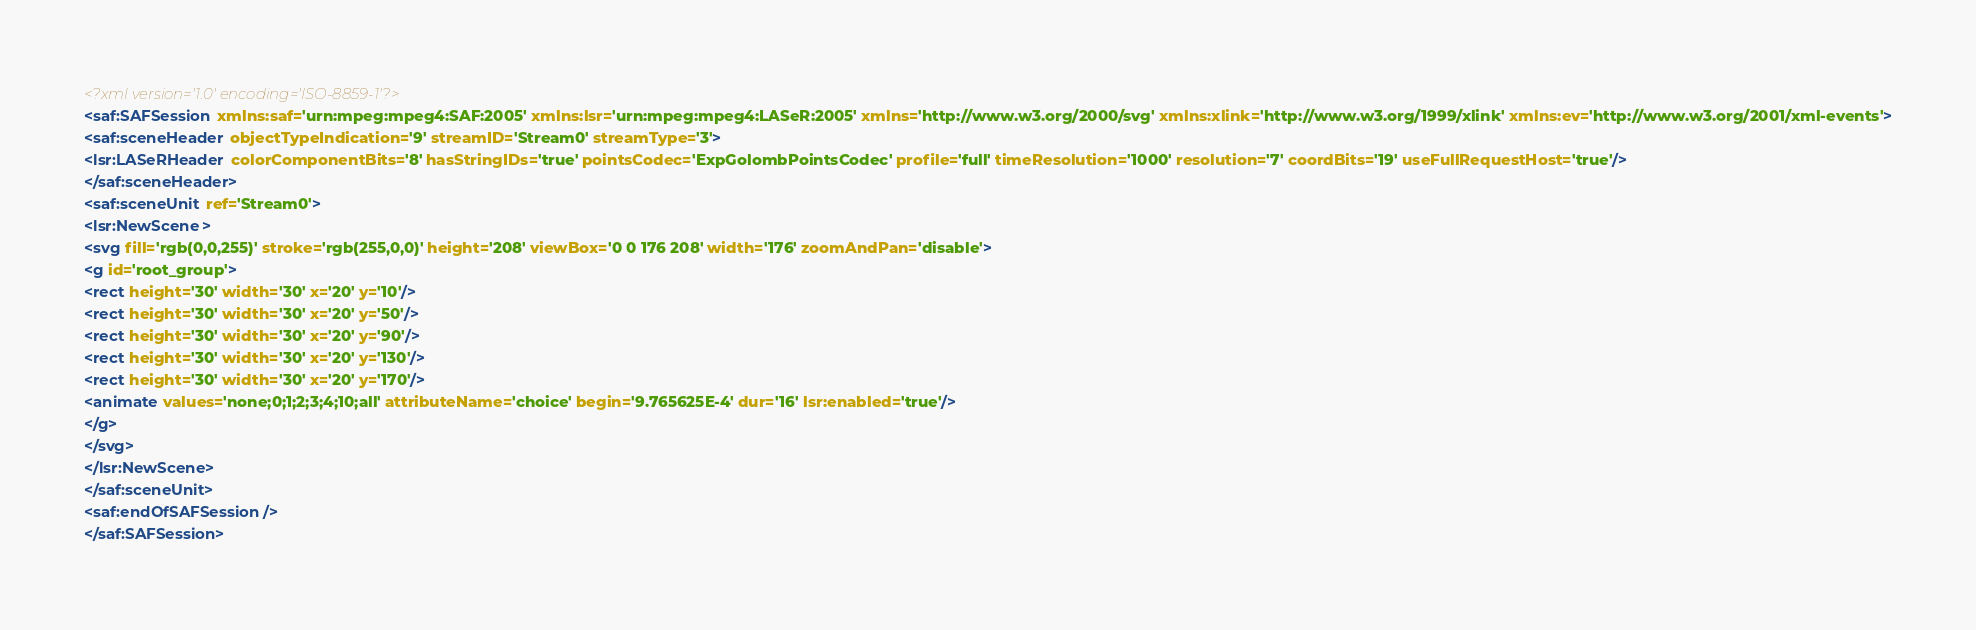<code> <loc_0><loc_0><loc_500><loc_500><_XML_><?xml version='1.0' encoding='ISO-8859-1'?>
<saf:SAFSession xmlns:saf='urn:mpeg:mpeg4:SAF:2005' xmlns:lsr='urn:mpeg:mpeg4:LASeR:2005' xmlns='http://www.w3.org/2000/svg' xmlns:xlink='http://www.w3.org/1999/xlink' xmlns:ev='http://www.w3.org/2001/xml-events'>
<saf:sceneHeader objectTypeIndication='9' streamID='Stream0' streamType='3'>
<lsr:LASeRHeader colorComponentBits='8' hasStringIDs='true' pointsCodec='ExpGolombPointsCodec' profile='full' timeResolution='1000' resolution='7' coordBits='19' useFullRequestHost='true'/>
</saf:sceneHeader>
<saf:sceneUnit ref='Stream0'>
<lsr:NewScene>
<svg fill='rgb(0,0,255)' stroke='rgb(255,0,0)' height='208' viewBox='0 0 176 208' width='176' zoomAndPan='disable'>
<g id='root_group'>
<rect height='30' width='30' x='20' y='10'/>
<rect height='30' width='30' x='20' y='50'/>
<rect height='30' width='30' x='20' y='90'/>
<rect height='30' width='30' x='20' y='130'/>
<rect height='30' width='30' x='20' y='170'/>
<animate values='none;0;1;2;3;4;10;all' attributeName='choice' begin='9.765625E-4' dur='16' lsr:enabled='true'/>
</g>
</svg>
</lsr:NewScene>
</saf:sceneUnit>
<saf:endOfSAFSession/>
</saf:SAFSession>
</code> 